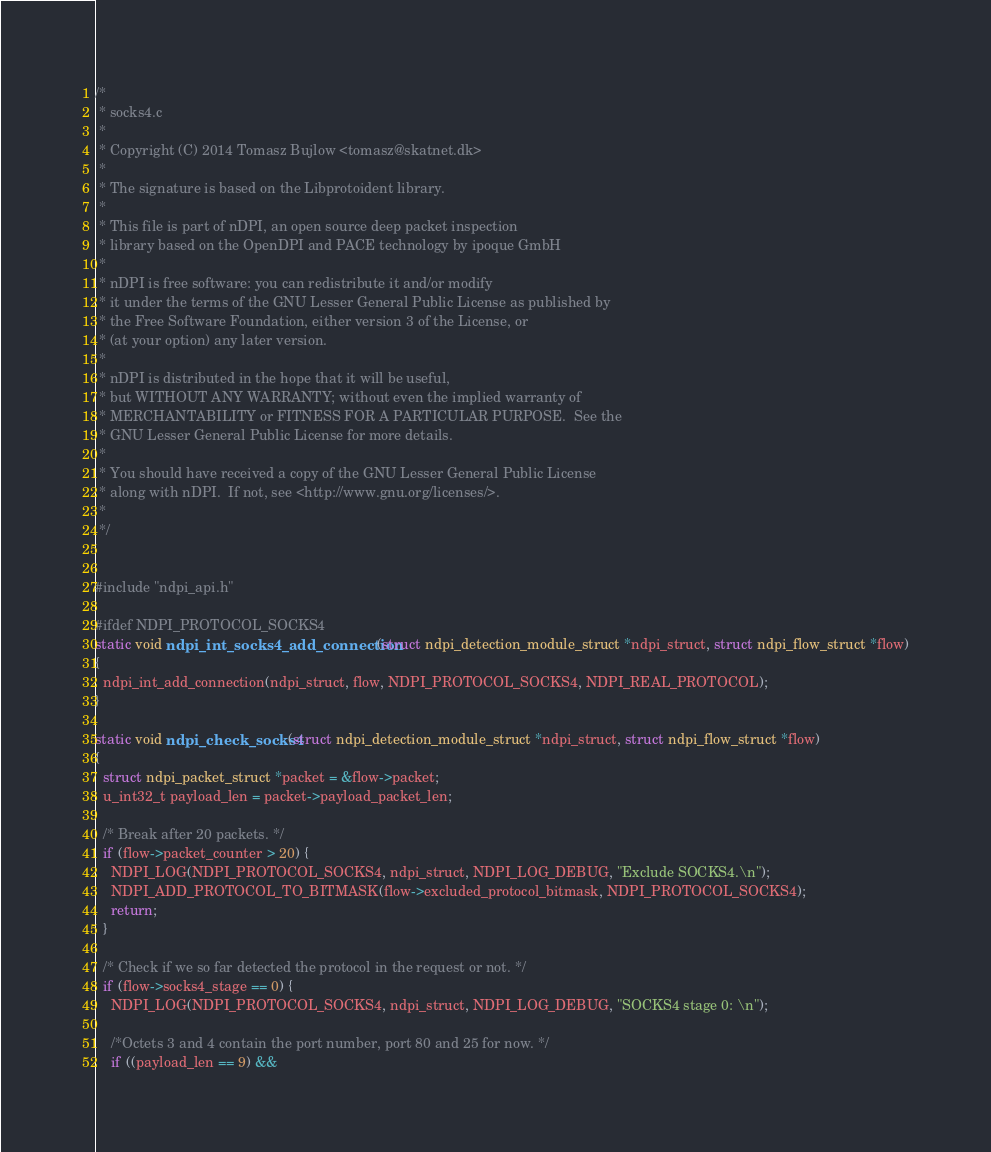<code> <loc_0><loc_0><loc_500><loc_500><_C_>/*
 * socks4.c
 *
 * Copyright (C) 2014 Tomasz Bujlow <tomasz@skatnet.dk>
 *
 * The signature is based on the Libprotoident library.
 *
 * This file is part of nDPI, an open source deep packet inspection
 * library based on the OpenDPI and PACE technology by ipoque GmbH
 *
 * nDPI is free software: you can redistribute it and/or modify
 * it under the terms of the GNU Lesser General Public License as published by
 * the Free Software Foundation, either version 3 of the License, or
 * (at your option) any later version.
 *
 * nDPI is distributed in the hope that it will be useful,
 * but WITHOUT ANY WARRANTY; without even the implied warranty of
 * MERCHANTABILITY or FITNESS FOR A PARTICULAR PURPOSE.  See the
 * GNU Lesser General Public License for more details.
 *
 * You should have received a copy of the GNU Lesser General Public License
 * along with nDPI.  If not, see <http://www.gnu.org/licenses/>.
 *
 */


#include "ndpi_api.h"

#ifdef NDPI_PROTOCOL_SOCKS4
static void ndpi_int_socks4_add_connection(struct ndpi_detection_module_struct *ndpi_struct, struct ndpi_flow_struct *flow)
{
  ndpi_int_add_connection(ndpi_struct, flow, NDPI_PROTOCOL_SOCKS4, NDPI_REAL_PROTOCOL);
}

static void ndpi_check_socks4(struct ndpi_detection_module_struct *ndpi_struct, struct ndpi_flow_struct *flow)
{
  struct ndpi_packet_struct *packet = &flow->packet;
  u_int32_t payload_len = packet->payload_packet_len;

  /* Break after 20 packets. */
  if (flow->packet_counter > 20) {
    NDPI_LOG(NDPI_PROTOCOL_SOCKS4, ndpi_struct, NDPI_LOG_DEBUG, "Exclude SOCKS4.\n");
    NDPI_ADD_PROTOCOL_TO_BITMASK(flow->excluded_protocol_bitmask, NDPI_PROTOCOL_SOCKS4);
    return;
  }

  /* Check if we so far detected the protocol in the request or not. */
  if (flow->socks4_stage == 0) {
    NDPI_LOG(NDPI_PROTOCOL_SOCKS4, ndpi_struct, NDPI_LOG_DEBUG, "SOCKS4 stage 0: \n");

    /*Octets 3 and 4 contain the port number, port 80 and 25 for now. */
    if ((payload_len == 9) &&</code> 